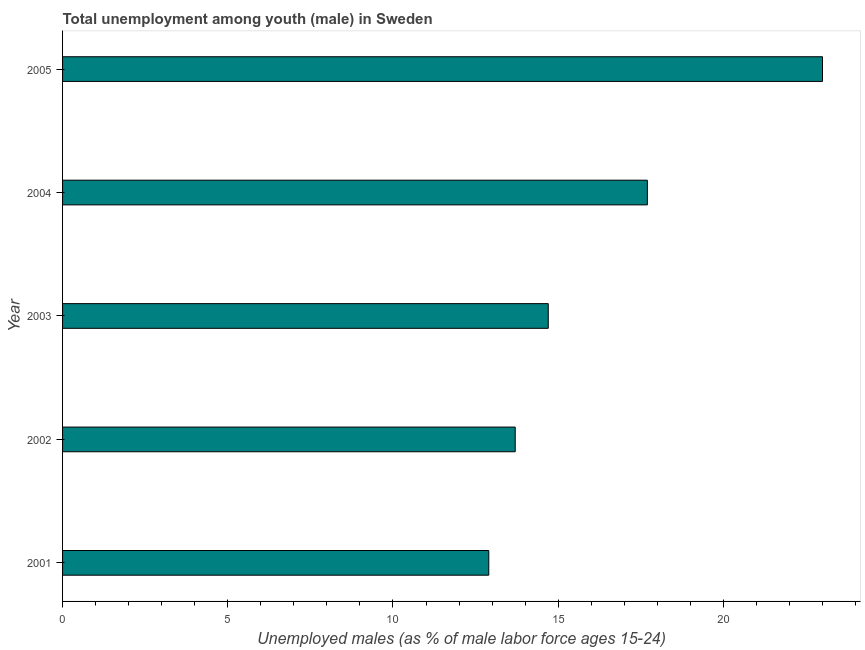Does the graph contain any zero values?
Provide a short and direct response. No. What is the title of the graph?
Make the answer very short. Total unemployment among youth (male) in Sweden. What is the label or title of the X-axis?
Your answer should be compact. Unemployed males (as % of male labor force ages 15-24). What is the label or title of the Y-axis?
Provide a succinct answer. Year. What is the unemployed male youth population in 2001?
Make the answer very short. 12.9. Across all years, what is the maximum unemployed male youth population?
Offer a very short reply. 23. Across all years, what is the minimum unemployed male youth population?
Your answer should be very brief. 12.9. In which year was the unemployed male youth population maximum?
Your response must be concise. 2005. What is the sum of the unemployed male youth population?
Provide a succinct answer. 82. What is the average unemployed male youth population per year?
Give a very brief answer. 16.4. What is the median unemployed male youth population?
Give a very brief answer. 14.7. Do a majority of the years between 2001 and 2004 (inclusive) have unemployed male youth population greater than 4 %?
Provide a succinct answer. Yes. What is the ratio of the unemployed male youth population in 2001 to that in 2004?
Your answer should be compact. 0.73. What is the difference between the highest and the second highest unemployed male youth population?
Offer a very short reply. 5.3. Is the sum of the unemployed male youth population in 2002 and 2005 greater than the maximum unemployed male youth population across all years?
Offer a terse response. Yes. In how many years, is the unemployed male youth population greater than the average unemployed male youth population taken over all years?
Give a very brief answer. 2. Are all the bars in the graph horizontal?
Offer a terse response. Yes. What is the Unemployed males (as % of male labor force ages 15-24) of 2001?
Give a very brief answer. 12.9. What is the Unemployed males (as % of male labor force ages 15-24) of 2002?
Your response must be concise. 13.7. What is the Unemployed males (as % of male labor force ages 15-24) in 2003?
Keep it short and to the point. 14.7. What is the Unemployed males (as % of male labor force ages 15-24) of 2004?
Give a very brief answer. 17.7. What is the difference between the Unemployed males (as % of male labor force ages 15-24) in 2001 and 2002?
Give a very brief answer. -0.8. What is the difference between the Unemployed males (as % of male labor force ages 15-24) in 2001 and 2004?
Offer a terse response. -4.8. What is the difference between the Unemployed males (as % of male labor force ages 15-24) in 2002 and 2005?
Give a very brief answer. -9.3. What is the difference between the Unemployed males (as % of male labor force ages 15-24) in 2003 and 2004?
Offer a terse response. -3. What is the difference between the Unemployed males (as % of male labor force ages 15-24) in 2003 and 2005?
Your response must be concise. -8.3. What is the ratio of the Unemployed males (as % of male labor force ages 15-24) in 2001 to that in 2002?
Make the answer very short. 0.94. What is the ratio of the Unemployed males (as % of male labor force ages 15-24) in 2001 to that in 2003?
Ensure brevity in your answer.  0.88. What is the ratio of the Unemployed males (as % of male labor force ages 15-24) in 2001 to that in 2004?
Offer a terse response. 0.73. What is the ratio of the Unemployed males (as % of male labor force ages 15-24) in 2001 to that in 2005?
Your answer should be very brief. 0.56. What is the ratio of the Unemployed males (as % of male labor force ages 15-24) in 2002 to that in 2003?
Your response must be concise. 0.93. What is the ratio of the Unemployed males (as % of male labor force ages 15-24) in 2002 to that in 2004?
Give a very brief answer. 0.77. What is the ratio of the Unemployed males (as % of male labor force ages 15-24) in 2002 to that in 2005?
Give a very brief answer. 0.6. What is the ratio of the Unemployed males (as % of male labor force ages 15-24) in 2003 to that in 2004?
Give a very brief answer. 0.83. What is the ratio of the Unemployed males (as % of male labor force ages 15-24) in 2003 to that in 2005?
Offer a terse response. 0.64. What is the ratio of the Unemployed males (as % of male labor force ages 15-24) in 2004 to that in 2005?
Make the answer very short. 0.77. 